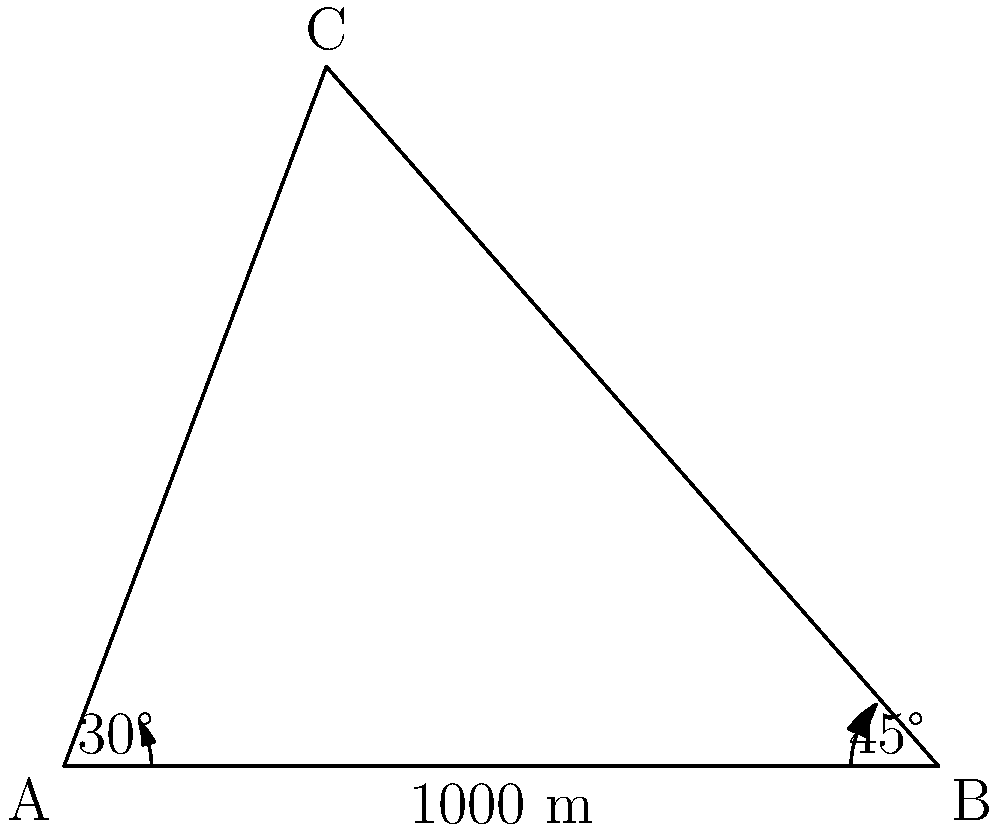During your retirement hikes in the Chama Valley, you've become interested in measuring the distances between mountain peaks. From a flat area between two peaks, you measure the angles of elevation to the tops of the peaks as 30° and 45°. The distance between your two observation points on the ground is 1000 meters. Using your knowledge of trigonometry, can you determine the distance between the two mountain peaks? Let's approach this step-by-step:

1) First, let's identify the given information:
   - The distance between observation points A and B is 1000 meters
   - The angle of elevation from A to C is 30°
   - The angle of elevation from B to C is 45°

2) We can use the tangent function to find the heights of the triangles:
   For triangle ACX (where X is the point directly below C on AB):
   $\tan(30°) = \frac{CX}{AX}$

   For triangle BCY (where Y is the point directly below C on AB):
   $\tan(45°) = \frac{CY}{BY}$

3) We don't know AX or BY, but we know AX + BY = 1000 m. Let's call AX = x. Then BY = 1000 - x.

4) Now we can set up two equations:
   $CX = x \tan(30°)$
   $CY = (1000 - x) \tan(45°)$

5) The total height of C above AB is the same in both triangles, so:
   $x \tan(30°) = (1000 - x) \tan(45°)$

6) Solving this equation:
   $x(\tan(30°) + \tan(45°)) = 1000 \tan(45°)$
   $x = \frac{1000 \tan(45°)}{\tan(30°) + \tan(45°)}$

7) $\tan(30°) = \frac{1}{\sqrt{3}}$ and $\tan(45°) = 1$, so:
   $x = \frac{1000 \cdot 1}{\frac{1}{\sqrt{3}} + 1} = \frac{1000\sqrt{3}}{\sqrt{3} + 1} \approx 634.0$ meters

8) Now we know AX and BX. We can use the Pythagorean theorem to find AC and BC:
   $AC = \sqrt{634.0^2 + (634.0 \tan(30°))^2} \approx 732.1$ meters
   $BC = \sqrt{365.9^2 + (365.9 \tan(45°))^2} \approx 517.4$ meters

9) Finally, we can use the law of cosines to find the distance between the peaks:
   $CC^2 = AC^2 + BC^2 - 2(AC)(BC)\cos(180° - (30° + 45°))$

10) Plugging in the values and solving:
    $CC = \sqrt{732.1^2 + 517.4^2 - 2(732.1)(517.4)\cos(105°)} \approx 1000$ meters
Answer: 1000 meters 